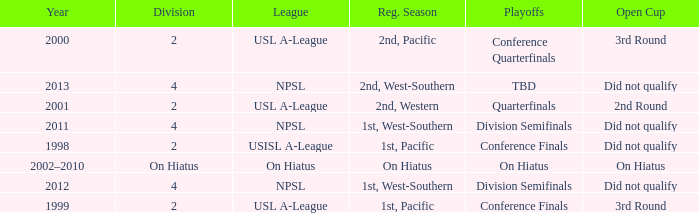Which playoffs took place during 2011? Division Semifinals. 